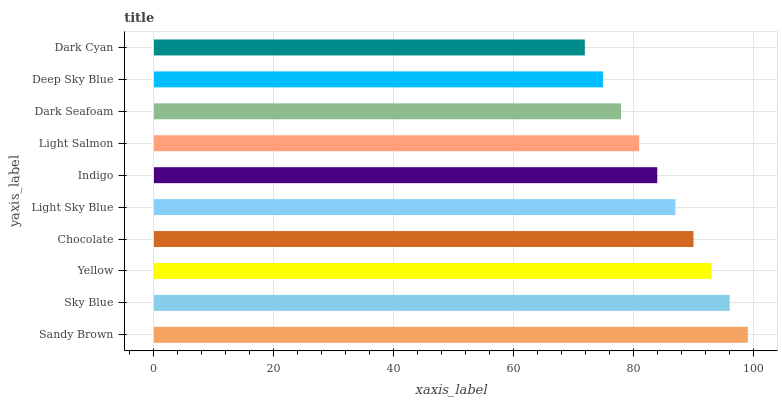Is Dark Cyan the minimum?
Answer yes or no. Yes. Is Sandy Brown the maximum?
Answer yes or no. Yes. Is Sky Blue the minimum?
Answer yes or no. No. Is Sky Blue the maximum?
Answer yes or no. No. Is Sandy Brown greater than Sky Blue?
Answer yes or no. Yes. Is Sky Blue less than Sandy Brown?
Answer yes or no. Yes. Is Sky Blue greater than Sandy Brown?
Answer yes or no. No. Is Sandy Brown less than Sky Blue?
Answer yes or no. No. Is Light Sky Blue the high median?
Answer yes or no. Yes. Is Indigo the low median?
Answer yes or no. Yes. Is Sky Blue the high median?
Answer yes or no. No. Is Sky Blue the low median?
Answer yes or no. No. 